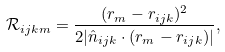Convert formula to latex. <formula><loc_0><loc_0><loc_500><loc_500>\mathcal { R } _ { i j k m } = \frac { ( r _ { m } - r _ { i j k } ) ^ { 2 } } { 2 | \hat { n } _ { i j k } \cdot ( r _ { m } - r _ { i j k } ) | } ,</formula> 